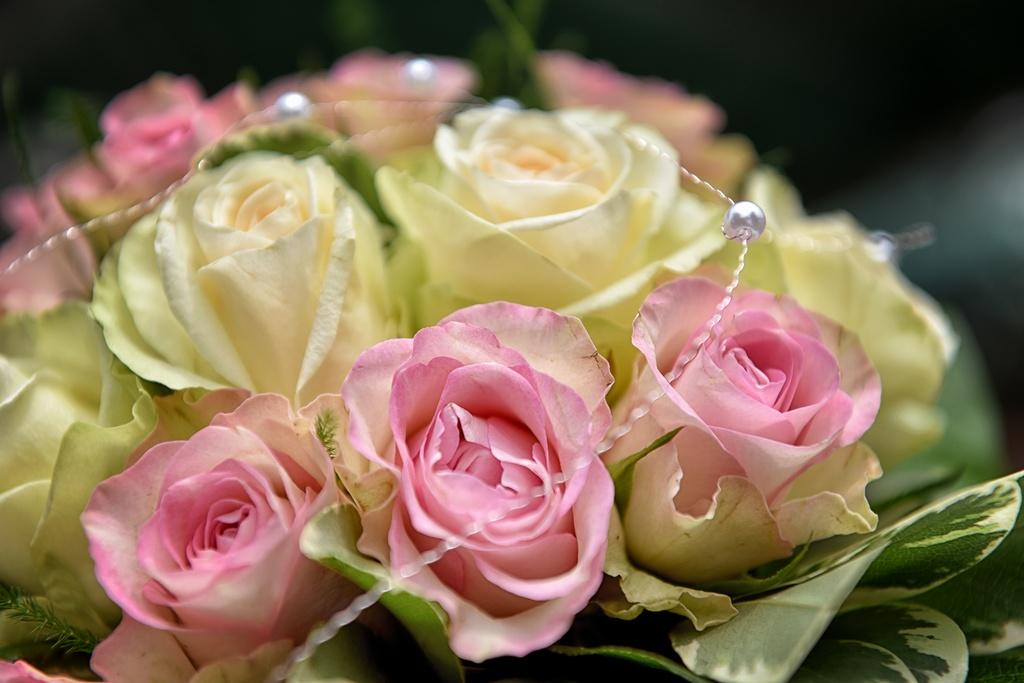What type of plants can be seen in the image? There are flowers in the image. What colors are the flowers? The flowers are in pink and yellow colors. Where are the leaves located in the image? The leaves are in the right corner of the image. What type of magic does the mother perform with the flowers in the image? There is no mother or magic present in the image; it only features flowers and leaves. 